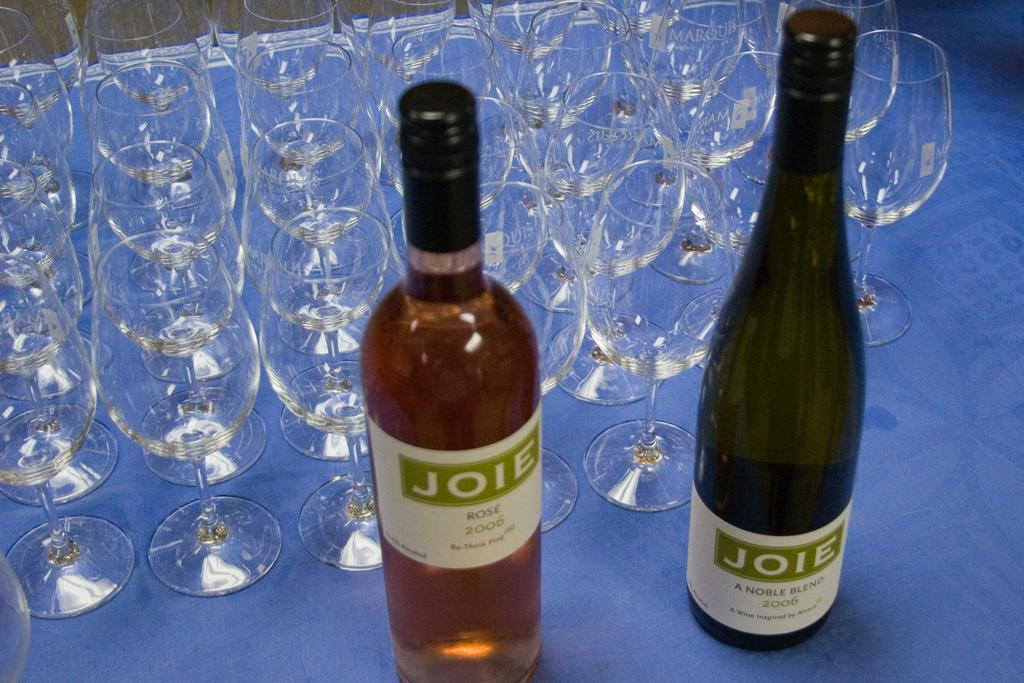What piece of furniture is present in the image? There is a table in the image. What objects are placed on the table? There are bottles and glasses on the table. How many eyes can be seen on the table in the image? There are no eyes visible on the table in the image. Are there any giants present in the image? There is no indication of giants in the image; it only features a table with bottles and glasses. 